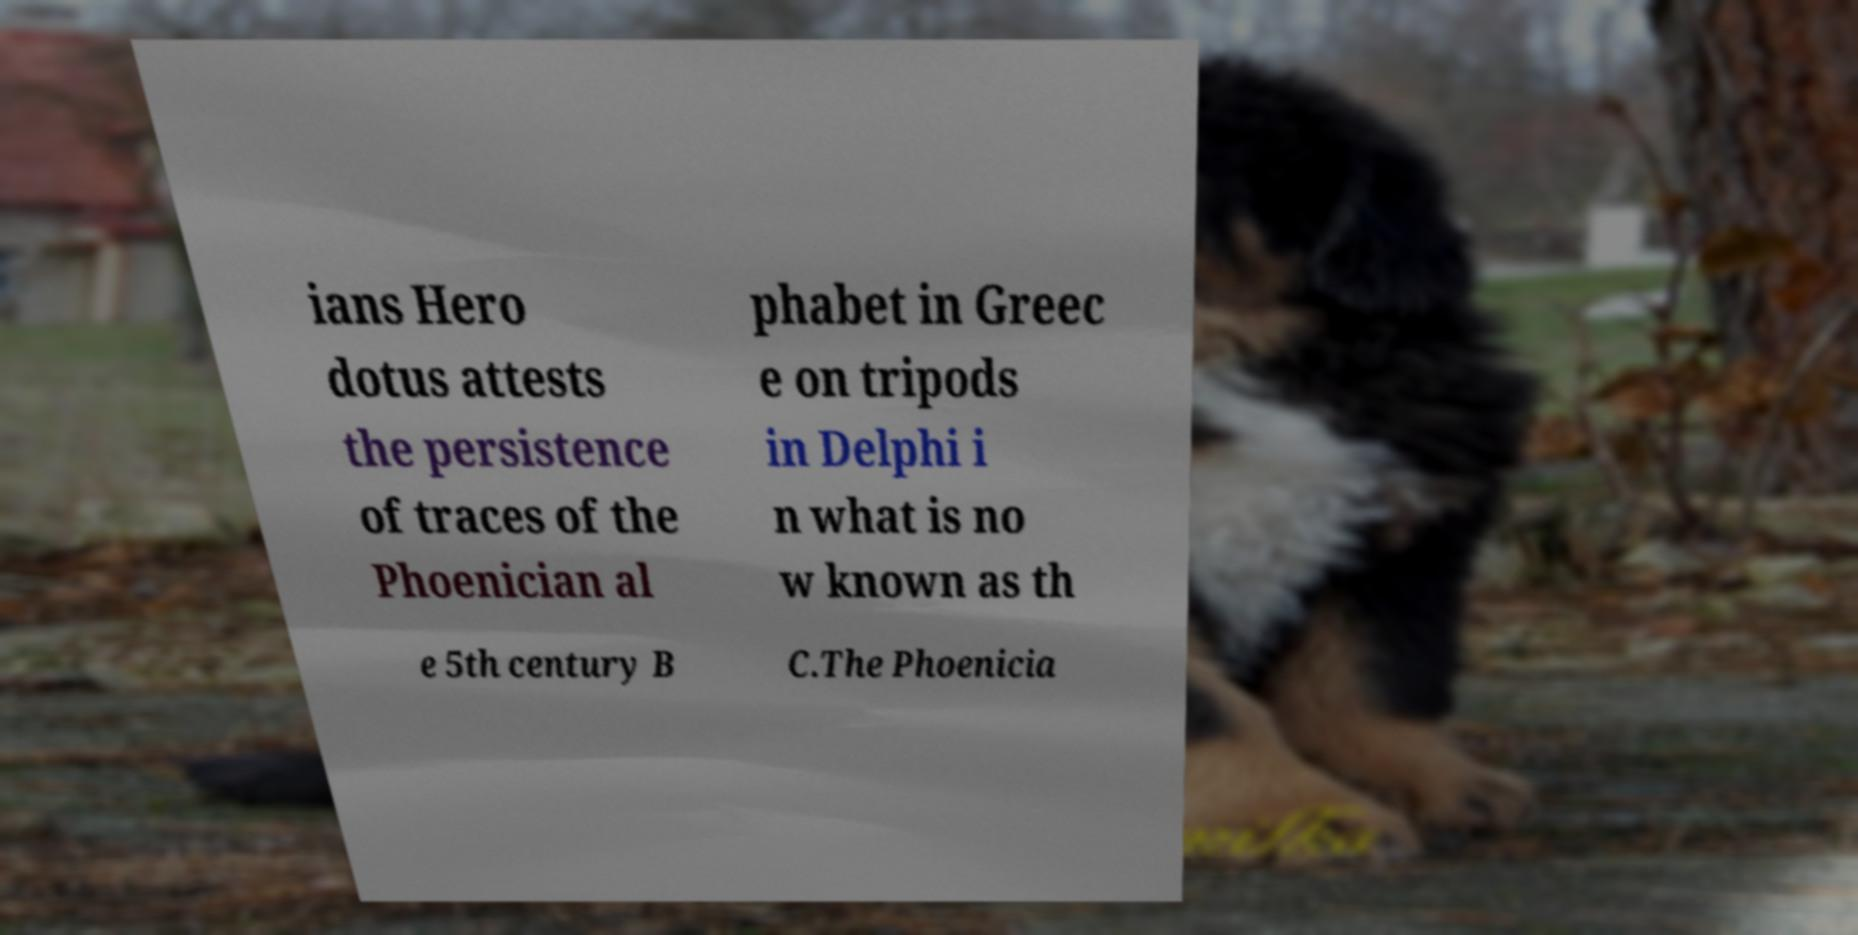What messages or text are displayed in this image? I need them in a readable, typed format. ians Hero dotus attests the persistence of traces of the Phoenician al phabet in Greec e on tripods in Delphi i n what is no w known as th e 5th century B C.The Phoenicia 